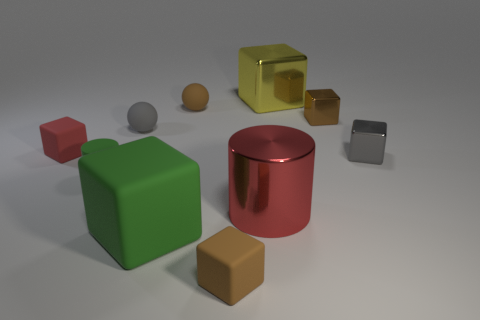Subtract all small gray blocks. How many blocks are left? 5 Subtract 4 blocks. How many blocks are left? 2 Subtract all yellow cubes. How many cubes are left? 5 Subtract all cyan blocks. Subtract all cyan cylinders. How many blocks are left? 6 Subtract all blocks. How many objects are left? 4 Subtract all small purple matte objects. Subtract all gray metal cubes. How many objects are left? 9 Add 6 tiny gray balls. How many tiny gray balls are left? 7 Add 7 big rubber things. How many big rubber things exist? 8 Subtract 0 blue cubes. How many objects are left? 10 